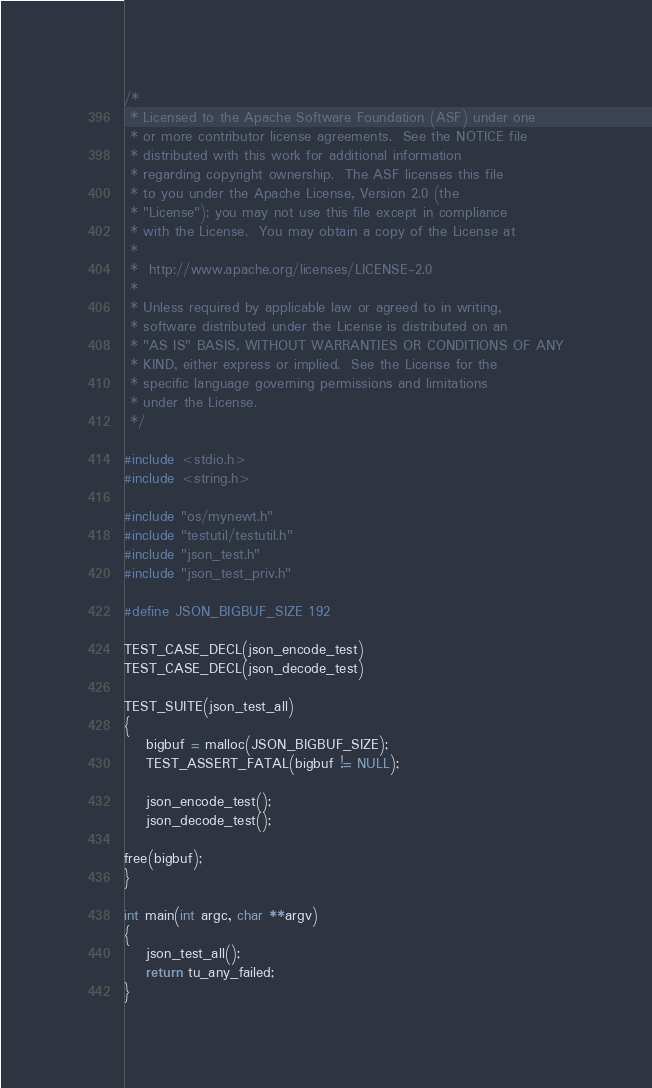Convert code to text. <code><loc_0><loc_0><loc_500><loc_500><_C_>/*
 * Licensed to the Apache Software Foundation (ASF) under one
 * or more contributor license agreements.  See the NOTICE file
 * distributed with this work for additional information
 * regarding copyright ownership.  The ASF licenses this file
 * to you under the Apache License, Version 2.0 (the
 * "License"); you may not use this file except in compliance
 * with the License.  You may obtain a copy of the License at
 *
 *  http://www.apache.org/licenses/LICENSE-2.0
 *
 * Unless required by applicable law or agreed to in writing,
 * software distributed under the License is distributed on an
 * "AS IS" BASIS, WITHOUT WARRANTIES OR CONDITIONS OF ANY
 * KIND, either express or implied.  See the License for the
 * specific language governing permissions and limitations
 * under the License.
 */

#include <stdio.h>
#include <string.h>

#include "os/mynewt.h"
#include "testutil/testutil.h"
#include "json_test.h"
#include "json_test_priv.h"

#define JSON_BIGBUF_SIZE 192

TEST_CASE_DECL(json_encode_test)
TEST_CASE_DECL(json_decode_test)

TEST_SUITE(json_test_all)
{
    bigbuf = malloc(JSON_BIGBUF_SIZE);
    TEST_ASSERT_FATAL(bigbuf != NULL);

    json_encode_test();
    json_decode_test();

free(bigbuf);
}

int main(int argc, char **argv)
{
    json_test_all();
    return tu_any_failed;
}
</code> 